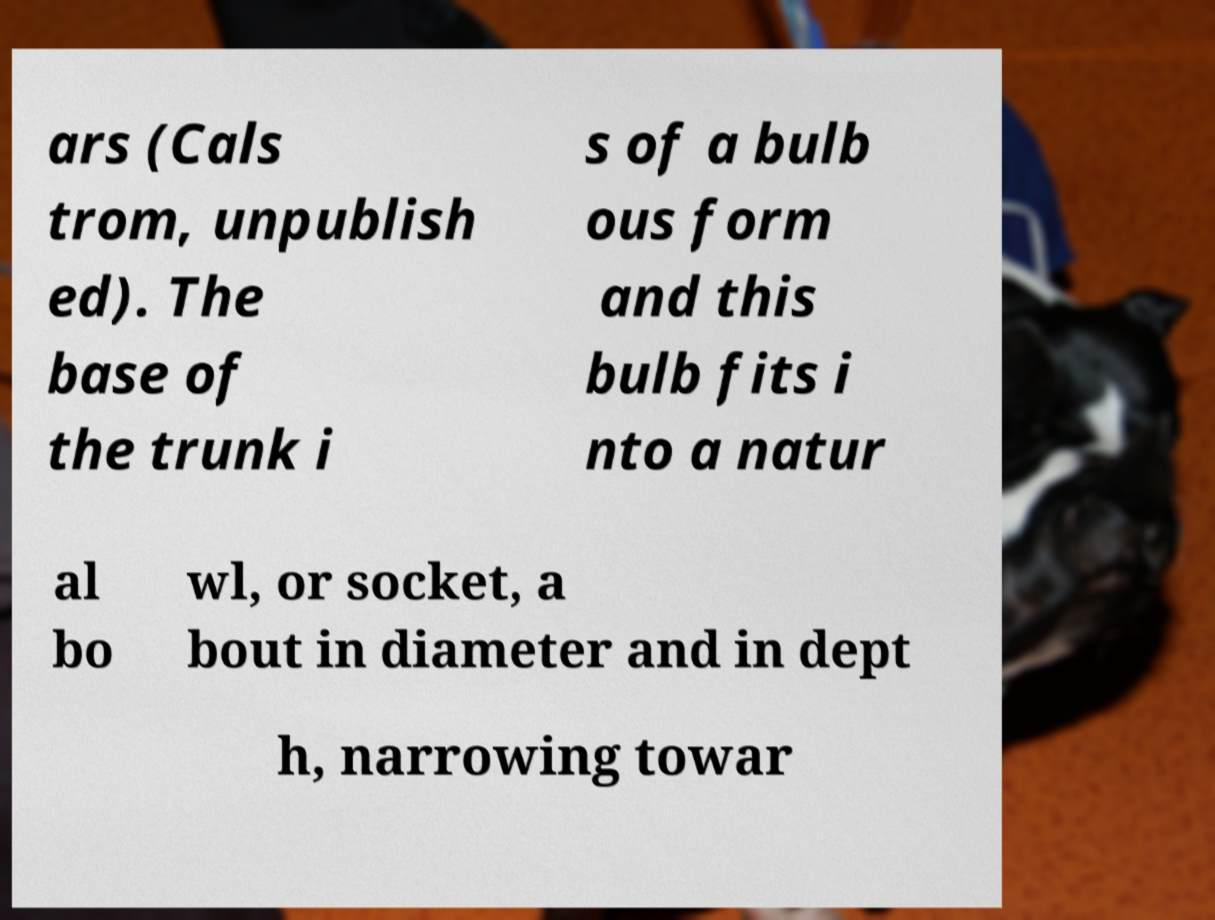Could you extract and type out the text from this image? ars (Cals trom, unpublish ed). The base of the trunk i s of a bulb ous form and this bulb fits i nto a natur al bo wl, or socket, a bout in diameter and in dept h, narrowing towar 